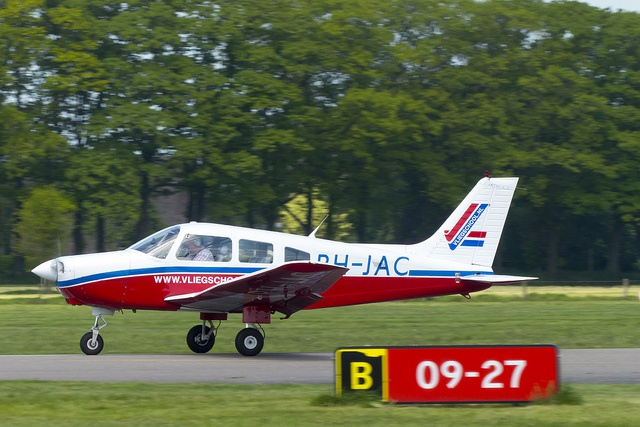Describe the objects in this image and their specific colors. I can see airplane in teal, white, black, and maroon tones and people in teal, darkgray, gray, and lavender tones in this image. 